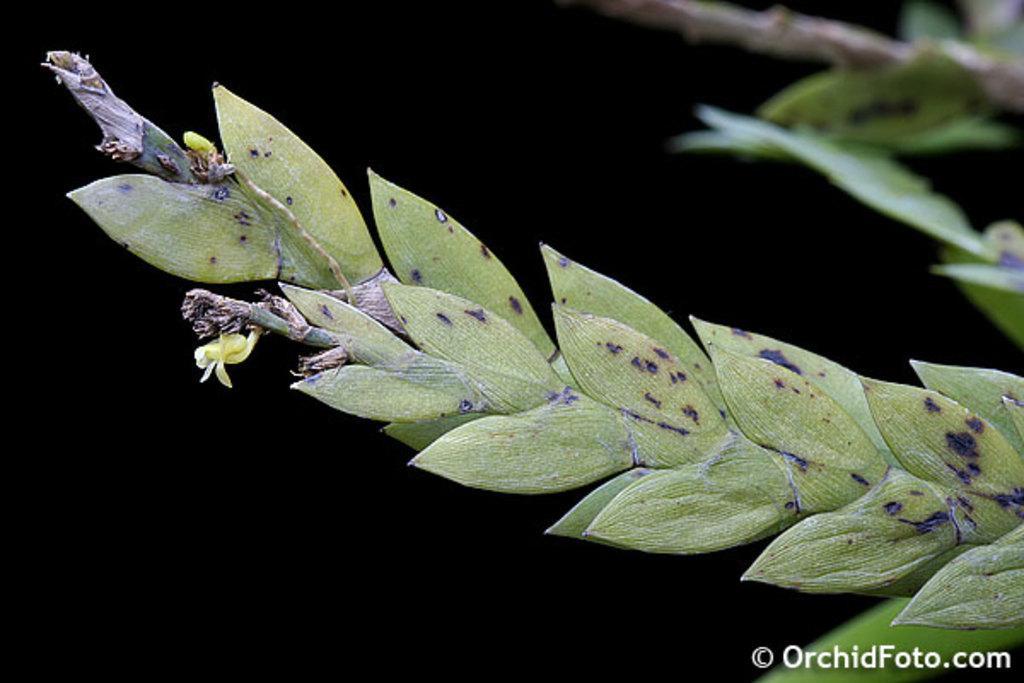Could you give a brief overview of what you see in this image? In this image I can see few green colour leaves in the front and on the right side of this image I can see few more leaves. In the background I can see black colour and on the bottom right side of this image I can see a watermark. 